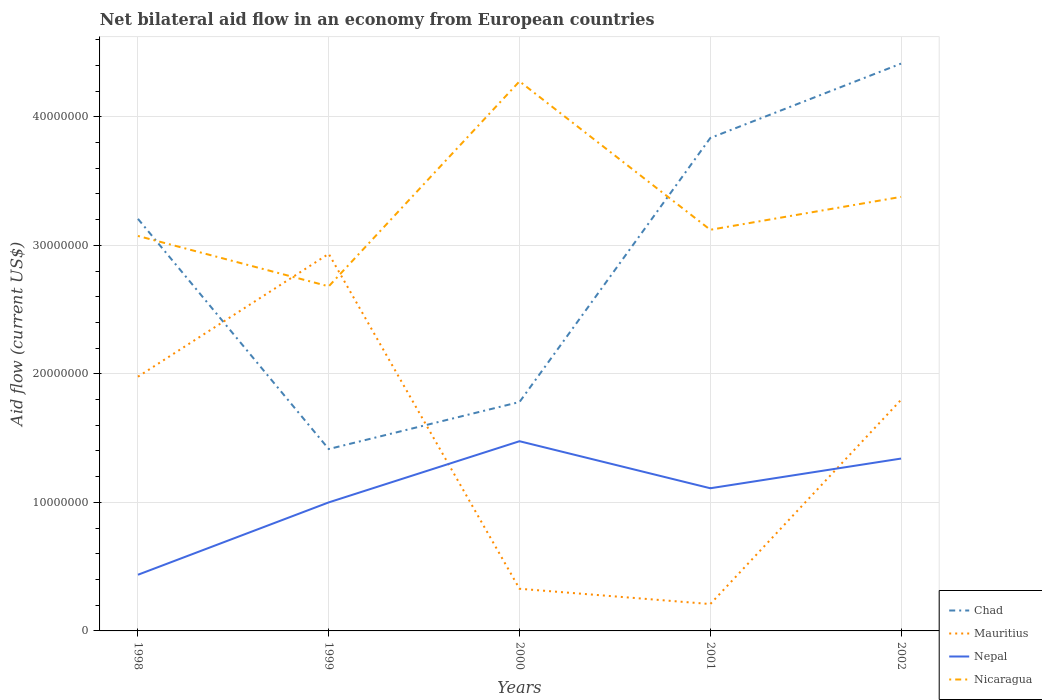How many different coloured lines are there?
Your answer should be very brief. 4. Is the number of lines equal to the number of legend labels?
Give a very brief answer. Yes. Across all years, what is the maximum net bilateral aid flow in Nepal?
Your answer should be very brief. 4.37e+06. What is the total net bilateral aid flow in Nicaragua in the graph?
Make the answer very short. 8.99e+06. What is the difference between the highest and the second highest net bilateral aid flow in Mauritius?
Your answer should be compact. 2.72e+07. Is the net bilateral aid flow in Mauritius strictly greater than the net bilateral aid flow in Nepal over the years?
Provide a short and direct response. No. How many lines are there?
Offer a terse response. 4. How many years are there in the graph?
Give a very brief answer. 5. What is the difference between two consecutive major ticks on the Y-axis?
Your answer should be compact. 1.00e+07. Are the values on the major ticks of Y-axis written in scientific E-notation?
Make the answer very short. No. How many legend labels are there?
Provide a succinct answer. 4. How are the legend labels stacked?
Offer a terse response. Vertical. What is the title of the graph?
Offer a terse response. Net bilateral aid flow in an economy from European countries. Does "Maldives" appear as one of the legend labels in the graph?
Your answer should be compact. No. What is the Aid flow (current US$) in Chad in 1998?
Keep it short and to the point. 3.21e+07. What is the Aid flow (current US$) in Mauritius in 1998?
Your answer should be very brief. 1.98e+07. What is the Aid flow (current US$) of Nepal in 1998?
Offer a very short reply. 4.37e+06. What is the Aid flow (current US$) of Nicaragua in 1998?
Offer a terse response. 3.07e+07. What is the Aid flow (current US$) in Chad in 1999?
Provide a short and direct response. 1.42e+07. What is the Aid flow (current US$) of Mauritius in 1999?
Provide a succinct answer. 2.93e+07. What is the Aid flow (current US$) in Nepal in 1999?
Give a very brief answer. 1.00e+07. What is the Aid flow (current US$) of Nicaragua in 1999?
Your answer should be very brief. 2.68e+07. What is the Aid flow (current US$) in Chad in 2000?
Ensure brevity in your answer.  1.78e+07. What is the Aid flow (current US$) in Mauritius in 2000?
Your answer should be compact. 3.28e+06. What is the Aid flow (current US$) of Nepal in 2000?
Your answer should be very brief. 1.48e+07. What is the Aid flow (current US$) of Nicaragua in 2000?
Your answer should be compact. 4.28e+07. What is the Aid flow (current US$) of Chad in 2001?
Offer a terse response. 3.84e+07. What is the Aid flow (current US$) of Mauritius in 2001?
Your response must be concise. 2.09e+06. What is the Aid flow (current US$) of Nepal in 2001?
Your answer should be very brief. 1.11e+07. What is the Aid flow (current US$) of Nicaragua in 2001?
Your answer should be compact. 3.12e+07. What is the Aid flow (current US$) in Chad in 2002?
Your response must be concise. 4.41e+07. What is the Aid flow (current US$) in Mauritius in 2002?
Give a very brief answer. 1.80e+07. What is the Aid flow (current US$) in Nepal in 2002?
Offer a very short reply. 1.34e+07. What is the Aid flow (current US$) in Nicaragua in 2002?
Your answer should be compact. 3.38e+07. Across all years, what is the maximum Aid flow (current US$) of Chad?
Provide a short and direct response. 4.41e+07. Across all years, what is the maximum Aid flow (current US$) of Mauritius?
Provide a succinct answer. 2.93e+07. Across all years, what is the maximum Aid flow (current US$) in Nepal?
Your answer should be compact. 1.48e+07. Across all years, what is the maximum Aid flow (current US$) of Nicaragua?
Ensure brevity in your answer.  4.28e+07. Across all years, what is the minimum Aid flow (current US$) of Chad?
Provide a succinct answer. 1.42e+07. Across all years, what is the minimum Aid flow (current US$) in Mauritius?
Provide a short and direct response. 2.09e+06. Across all years, what is the minimum Aid flow (current US$) of Nepal?
Make the answer very short. 4.37e+06. Across all years, what is the minimum Aid flow (current US$) in Nicaragua?
Ensure brevity in your answer.  2.68e+07. What is the total Aid flow (current US$) of Chad in the graph?
Your response must be concise. 1.47e+08. What is the total Aid flow (current US$) of Mauritius in the graph?
Offer a terse response. 7.25e+07. What is the total Aid flow (current US$) in Nepal in the graph?
Provide a succinct answer. 5.36e+07. What is the total Aid flow (current US$) in Nicaragua in the graph?
Make the answer very short. 1.65e+08. What is the difference between the Aid flow (current US$) of Chad in 1998 and that in 1999?
Keep it short and to the point. 1.79e+07. What is the difference between the Aid flow (current US$) of Mauritius in 1998 and that in 1999?
Give a very brief answer. -9.56e+06. What is the difference between the Aid flow (current US$) in Nepal in 1998 and that in 1999?
Provide a short and direct response. -5.63e+06. What is the difference between the Aid flow (current US$) in Nicaragua in 1998 and that in 1999?
Keep it short and to the point. 3.92e+06. What is the difference between the Aid flow (current US$) in Chad in 1998 and that in 2000?
Your response must be concise. 1.42e+07. What is the difference between the Aid flow (current US$) of Mauritius in 1998 and that in 2000?
Keep it short and to the point. 1.65e+07. What is the difference between the Aid flow (current US$) of Nepal in 1998 and that in 2000?
Your answer should be very brief. -1.04e+07. What is the difference between the Aid flow (current US$) of Nicaragua in 1998 and that in 2000?
Provide a short and direct response. -1.20e+07. What is the difference between the Aid flow (current US$) in Chad in 1998 and that in 2001?
Keep it short and to the point. -6.29e+06. What is the difference between the Aid flow (current US$) in Mauritius in 1998 and that in 2001?
Offer a very short reply. 1.77e+07. What is the difference between the Aid flow (current US$) in Nepal in 1998 and that in 2001?
Provide a succinct answer. -6.73e+06. What is the difference between the Aid flow (current US$) of Nicaragua in 1998 and that in 2001?
Offer a terse response. -4.80e+05. What is the difference between the Aid flow (current US$) in Chad in 1998 and that in 2002?
Provide a short and direct response. -1.21e+07. What is the difference between the Aid flow (current US$) in Mauritius in 1998 and that in 2002?
Your answer should be compact. 1.80e+06. What is the difference between the Aid flow (current US$) in Nepal in 1998 and that in 2002?
Offer a very short reply. -9.04e+06. What is the difference between the Aid flow (current US$) of Nicaragua in 1998 and that in 2002?
Offer a very short reply. -3.04e+06. What is the difference between the Aid flow (current US$) in Chad in 1999 and that in 2000?
Provide a succinct answer. -3.66e+06. What is the difference between the Aid flow (current US$) in Mauritius in 1999 and that in 2000?
Your answer should be compact. 2.61e+07. What is the difference between the Aid flow (current US$) in Nepal in 1999 and that in 2000?
Offer a terse response. -4.76e+06. What is the difference between the Aid flow (current US$) in Nicaragua in 1999 and that in 2000?
Your answer should be very brief. -1.60e+07. What is the difference between the Aid flow (current US$) of Chad in 1999 and that in 2001?
Your response must be concise. -2.42e+07. What is the difference between the Aid flow (current US$) of Mauritius in 1999 and that in 2001?
Your response must be concise. 2.72e+07. What is the difference between the Aid flow (current US$) of Nepal in 1999 and that in 2001?
Offer a very short reply. -1.10e+06. What is the difference between the Aid flow (current US$) of Nicaragua in 1999 and that in 2001?
Keep it short and to the point. -4.40e+06. What is the difference between the Aid flow (current US$) of Chad in 1999 and that in 2002?
Your answer should be compact. -3.00e+07. What is the difference between the Aid flow (current US$) of Mauritius in 1999 and that in 2002?
Your answer should be very brief. 1.14e+07. What is the difference between the Aid flow (current US$) in Nepal in 1999 and that in 2002?
Give a very brief answer. -3.41e+06. What is the difference between the Aid flow (current US$) in Nicaragua in 1999 and that in 2002?
Keep it short and to the point. -6.96e+06. What is the difference between the Aid flow (current US$) in Chad in 2000 and that in 2001?
Ensure brevity in your answer.  -2.05e+07. What is the difference between the Aid flow (current US$) of Mauritius in 2000 and that in 2001?
Keep it short and to the point. 1.19e+06. What is the difference between the Aid flow (current US$) of Nepal in 2000 and that in 2001?
Your response must be concise. 3.66e+06. What is the difference between the Aid flow (current US$) in Nicaragua in 2000 and that in 2001?
Make the answer very short. 1.16e+07. What is the difference between the Aid flow (current US$) in Chad in 2000 and that in 2002?
Your response must be concise. -2.63e+07. What is the difference between the Aid flow (current US$) of Mauritius in 2000 and that in 2002?
Your response must be concise. -1.47e+07. What is the difference between the Aid flow (current US$) of Nepal in 2000 and that in 2002?
Give a very brief answer. 1.35e+06. What is the difference between the Aid flow (current US$) in Nicaragua in 2000 and that in 2002?
Offer a very short reply. 8.99e+06. What is the difference between the Aid flow (current US$) in Chad in 2001 and that in 2002?
Your answer should be very brief. -5.79e+06. What is the difference between the Aid flow (current US$) of Mauritius in 2001 and that in 2002?
Your response must be concise. -1.59e+07. What is the difference between the Aid flow (current US$) of Nepal in 2001 and that in 2002?
Provide a succinct answer. -2.31e+06. What is the difference between the Aid flow (current US$) in Nicaragua in 2001 and that in 2002?
Make the answer very short. -2.56e+06. What is the difference between the Aid flow (current US$) in Chad in 1998 and the Aid flow (current US$) in Mauritius in 1999?
Offer a very short reply. 2.72e+06. What is the difference between the Aid flow (current US$) in Chad in 1998 and the Aid flow (current US$) in Nepal in 1999?
Provide a short and direct response. 2.21e+07. What is the difference between the Aid flow (current US$) in Chad in 1998 and the Aid flow (current US$) in Nicaragua in 1999?
Give a very brief answer. 5.25e+06. What is the difference between the Aid flow (current US$) in Mauritius in 1998 and the Aid flow (current US$) in Nepal in 1999?
Give a very brief answer. 9.78e+06. What is the difference between the Aid flow (current US$) in Mauritius in 1998 and the Aid flow (current US$) in Nicaragua in 1999?
Your answer should be compact. -7.03e+06. What is the difference between the Aid flow (current US$) in Nepal in 1998 and the Aid flow (current US$) in Nicaragua in 1999?
Keep it short and to the point. -2.24e+07. What is the difference between the Aid flow (current US$) of Chad in 1998 and the Aid flow (current US$) of Mauritius in 2000?
Your response must be concise. 2.88e+07. What is the difference between the Aid flow (current US$) in Chad in 1998 and the Aid flow (current US$) in Nepal in 2000?
Your response must be concise. 1.73e+07. What is the difference between the Aid flow (current US$) in Chad in 1998 and the Aid flow (current US$) in Nicaragua in 2000?
Your answer should be compact. -1.07e+07. What is the difference between the Aid flow (current US$) of Mauritius in 1998 and the Aid flow (current US$) of Nepal in 2000?
Your response must be concise. 5.02e+06. What is the difference between the Aid flow (current US$) in Mauritius in 1998 and the Aid flow (current US$) in Nicaragua in 2000?
Ensure brevity in your answer.  -2.30e+07. What is the difference between the Aid flow (current US$) of Nepal in 1998 and the Aid flow (current US$) of Nicaragua in 2000?
Keep it short and to the point. -3.84e+07. What is the difference between the Aid flow (current US$) in Chad in 1998 and the Aid flow (current US$) in Mauritius in 2001?
Offer a very short reply. 3.00e+07. What is the difference between the Aid flow (current US$) of Chad in 1998 and the Aid flow (current US$) of Nepal in 2001?
Your response must be concise. 2.10e+07. What is the difference between the Aid flow (current US$) of Chad in 1998 and the Aid flow (current US$) of Nicaragua in 2001?
Keep it short and to the point. 8.50e+05. What is the difference between the Aid flow (current US$) of Mauritius in 1998 and the Aid flow (current US$) of Nepal in 2001?
Ensure brevity in your answer.  8.68e+06. What is the difference between the Aid flow (current US$) in Mauritius in 1998 and the Aid flow (current US$) in Nicaragua in 2001?
Ensure brevity in your answer.  -1.14e+07. What is the difference between the Aid flow (current US$) of Nepal in 1998 and the Aid flow (current US$) of Nicaragua in 2001?
Provide a short and direct response. -2.68e+07. What is the difference between the Aid flow (current US$) of Chad in 1998 and the Aid flow (current US$) of Mauritius in 2002?
Offer a very short reply. 1.41e+07. What is the difference between the Aid flow (current US$) in Chad in 1998 and the Aid flow (current US$) in Nepal in 2002?
Provide a short and direct response. 1.86e+07. What is the difference between the Aid flow (current US$) of Chad in 1998 and the Aid flow (current US$) of Nicaragua in 2002?
Make the answer very short. -1.71e+06. What is the difference between the Aid flow (current US$) in Mauritius in 1998 and the Aid flow (current US$) in Nepal in 2002?
Make the answer very short. 6.37e+06. What is the difference between the Aid flow (current US$) of Mauritius in 1998 and the Aid flow (current US$) of Nicaragua in 2002?
Your answer should be very brief. -1.40e+07. What is the difference between the Aid flow (current US$) of Nepal in 1998 and the Aid flow (current US$) of Nicaragua in 2002?
Keep it short and to the point. -2.94e+07. What is the difference between the Aid flow (current US$) in Chad in 1999 and the Aid flow (current US$) in Mauritius in 2000?
Keep it short and to the point. 1.09e+07. What is the difference between the Aid flow (current US$) of Chad in 1999 and the Aid flow (current US$) of Nepal in 2000?
Give a very brief answer. -6.10e+05. What is the difference between the Aid flow (current US$) in Chad in 1999 and the Aid flow (current US$) in Nicaragua in 2000?
Provide a succinct answer. -2.86e+07. What is the difference between the Aid flow (current US$) of Mauritius in 1999 and the Aid flow (current US$) of Nepal in 2000?
Offer a terse response. 1.46e+07. What is the difference between the Aid flow (current US$) in Mauritius in 1999 and the Aid flow (current US$) in Nicaragua in 2000?
Provide a short and direct response. -1.34e+07. What is the difference between the Aid flow (current US$) in Nepal in 1999 and the Aid flow (current US$) in Nicaragua in 2000?
Your answer should be very brief. -3.28e+07. What is the difference between the Aid flow (current US$) in Chad in 1999 and the Aid flow (current US$) in Mauritius in 2001?
Your response must be concise. 1.21e+07. What is the difference between the Aid flow (current US$) of Chad in 1999 and the Aid flow (current US$) of Nepal in 2001?
Make the answer very short. 3.05e+06. What is the difference between the Aid flow (current US$) of Chad in 1999 and the Aid flow (current US$) of Nicaragua in 2001?
Your answer should be compact. -1.71e+07. What is the difference between the Aid flow (current US$) in Mauritius in 1999 and the Aid flow (current US$) in Nepal in 2001?
Provide a short and direct response. 1.82e+07. What is the difference between the Aid flow (current US$) of Mauritius in 1999 and the Aid flow (current US$) of Nicaragua in 2001?
Offer a very short reply. -1.87e+06. What is the difference between the Aid flow (current US$) in Nepal in 1999 and the Aid flow (current US$) in Nicaragua in 2001?
Your answer should be compact. -2.12e+07. What is the difference between the Aid flow (current US$) in Chad in 1999 and the Aid flow (current US$) in Mauritius in 2002?
Offer a very short reply. -3.83e+06. What is the difference between the Aid flow (current US$) of Chad in 1999 and the Aid flow (current US$) of Nepal in 2002?
Your answer should be compact. 7.40e+05. What is the difference between the Aid flow (current US$) in Chad in 1999 and the Aid flow (current US$) in Nicaragua in 2002?
Provide a succinct answer. -1.96e+07. What is the difference between the Aid flow (current US$) of Mauritius in 1999 and the Aid flow (current US$) of Nepal in 2002?
Keep it short and to the point. 1.59e+07. What is the difference between the Aid flow (current US$) in Mauritius in 1999 and the Aid flow (current US$) in Nicaragua in 2002?
Ensure brevity in your answer.  -4.43e+06. What is the difference between the Aid flow (current US$) of Nepal in 1999 and the Aid flow (current US$) of Nicaragua in 2002?
Keep it short and to the point. -2.38e+07. What is the difference between the Aid flow (current US$) of Chad in 2000 and the Aid flow (current US$) of Mauritius in 2001?
Your response must be concise. 1.57e+07. What is the difference between the Aid flow (current US$) of Chad in 2000 and the Aid flow (current US$) of Nepal in 2001?
Provide a short and direct response. 6.71e+06. What is the difference between the Aid flow (current US$) in Chad in 2000 and the Aid flow (current US$) in Nicaragua in 2001?
Provide a succinct answer. -1.34e+07. What is the difference between the Aid flow (current US$) in Mauritius in 2000 and the Aid flow (current US$) in Nepal in 2001?
Your answer should be very brief. -7.82e+06. What is the difference between the Aid flow (current US$) in Mauritius in 2000 and the Aid flow (current US$) in Nicaragua in 2001?
Your answer should be very brief. -2.79e+07. What is the difference between the Aid flow (current US$) in Nepal in 2000 and the Aid flow (current US$) in Nicaragua in 2001?
Your answer should be very brief. -1.64e+07. What is the difference between the Aid flow (current US$) of Chad in 2000 and the Aid flow (current US$) of Nepal in 2002?
Make the answer very short. 4.40e+06. What is the difference between the Aid flow (current US$) of Chad in 2000 and the Aid flow (current US$) of Nicaragua in 2002?
Offer a terse response. -1.60e+07. What is the difference between the Aid flow (current US$) of Mauritius in 2000 and the Aid flow (current US$) of Nepal in 2002?
Keep it short and to the point. -1.01e+07. What is the difference between the Aid flow (current US$) in Mauritius in 2000 and the Aid flow (current US$) in Nicaragua in 2002?
Your response must be concise. -3.05e+07. What is the difference between the Aid flow (current US$) in Nepal in 2000 and the Aid flow (current US$) in Nicaragua in 2002?
Offer a terse response. -1.90e+07. What is the difference between the Aid flow (current US$) of Chad in 2001 and the Aid flow (current US$) of Mauritius in 2002?
Your response must be concise. 2.04e+07. What is the difference between the Aid flow (current US$) of Chad in 2001 and the Aid flow (current US$) of Nepal in 2002?
Your response must be concise. 2.49e+07. What is the difference between the Aid flow (current US$) of Chad in 2001 and the Aid flow (current US$) of Nicaragua in 2002?
Offer a terse response. 4.58e+06. What is the difference between the Aid flow (current US$) in Mauritius in 2001 and the Aid flow (current US$) in Nepal in 2002?
Give a very brief answer. -1.13e+07. What is the difference between the Aid flow (current US$) in Mauritius in 2001 and the Aid flow (current US$) in Nicaragua in 2002?
Provide a short and direct response. -3.17e+07. What is the difference between the Aid flow (current US$) of Nepal in 2001 and the Aid flow (current US$) of Nicaragua in 2002?
Keep it short and to the point. -2.27e+07. What is the average Aid flow (current US$) of Chad per year?
Offer a terse response. 2.93e+07. What is the average Aid flow (current US$) of Mauritius per year?
Your answer should be very brief. 1.45e+07. What is the average Aid flow (current US$) of Nepal per year?
Offer a terse response. 1.07e+07. What is the average Aid flow (current US$) of Nicaragua per year?
Provide a succinct answer. 3.31e+07. In the year 1998, what is the difference between the Aid flow (current US$) of Chad and Aid flow (current US$) of Mauritius?
Ensure brevity in your answer.  1.23e+07. In the year 1998, what is the difference between the Aid flow (current US$) of Chad and Aid flow (current US$) of Nepal?
Offer a terse response. 2.77e+07. In the year 1998, what is the difference between the Aid flow (current US$) in Chad and Aid flow (current US$) in Nicaragua?
Give a very brief answer. 1.33e+06. In the year 1998, what is the difference between the Aid flow (current US$) in Mauritius and Aid flow (current US$) in Nepal?
Your answer should be compact. 1.54e+07. In the year 1998, what is the difference between the Aid flow (current US$) of Mauritius and Aid flow (current US$) of Nicaragua?
Offer a very short reply. -1.10e+07. In the year 1998, what is the difference between the Aid flow (current US$) of Nepal and Aid flow (current US$) of Nicaragua?
Offer a terse response. -2.64e+07. In the year 1999, what is the difference between the Aid flow (current US$) in Chad and Aid flow (current US$) in Mauritius?
Offer a terse response. -1.52e+07. In the year 1999, what is the difference between the Aid flow (current US$) in Chad and Aid flow (current US$) in Nepal?
Make the answer very short. 4.15e+06. In the year 1999, what is the difference between the Aid flow (current US$) of Chad and Aid flow (current US$) of Nicaragua?
Give a very brief answer. -1.27e+07. In the year 1999, what is the difference between the Aid flow (current US$) of Mauritius and Aid flow (current US$) of Nepal?
Make the answer very short. 1.93e+07. In the year 1999, what is the difference between the Aid flow (current US$) in Mauritius and Aid flow (current US$) in Nicaragua?
Offer a terse response. 2.53e+06. In the year 1999, what is the difference between the Aid flow (current US$) of Nepal and Aid flow (current US$) of Nicaragua?
Provide a succinct answer. -1.68e+07. In the year 2000, what is the difference between the Aid flow (current US$) of Chad and Aid flow (current US$) of Mauritius?
Your answer should be compact. 1.45e+07. In the year 2000, what is the difference between the Aid flow (current US$) of Chad and Aid flow (current US$) of Nepal?
Give a very brief answer. 3.05e+06. In the year 2000, what is the difference between the Aid flow (current US$) in Chad and Aid flow (current US$) in Nicaragua?
Give a very brief answer. -2.50e+07. In the year 2000, what is the difference between the Aid flow (current US$) in Mauritius and Aid flow (current US$) in Nepal?
Your answer should be very brief. -1.15e+07. In the year 2000, what is the difference between the Aid flow (current US$) of Mauritius and Aid flow (current US$) of Nicaragua?
Give a very brief answer. -3.95e+07. In the year 2000, what is the difference between the Aid flow (current US$) of Nepal and Aid flow (current US$) of Nicaragua?
Keep it short and to the point. -2.80e+07. In the year 2001, what is the difference between the Aid flow (current US$) of Chad and Aid flow (current US$) of Mauritius?
Your answer should be very brief. 3.63e+07. In the year 2001, what is the difference between the Aid flow (current US$) in Chad and Aid flow (current US$) in Nepal?
Provide a short and direct response. 2.72e+07. In the year 2001, what is the difference between the Aid flow (current US$) in Chad and Aid flow (current US$) in Nicaragua?
Provide a short and direct response. 7.14e+06. In the year 2001, what is the difference between the Aid flow (current US$) of Mauritius and Aid flow (current US$) of Nepal?
Offer a very short reply. -9.01e+06. In the year 2001, what is the difference between the Aid flow (current US$) of Mauritius and Aid flow (current US$) of Nicaragua?
Provide a succinct answer. -2.91e+07. In the year 2001, what is the difference between the Aid flow (current US$) in Nepal and Aid flow (current US$) in Nicaragua?
Your answer should be very brief. -2.01e+07. In the year 2002, what is the difference between the Aid flow (current US$) of Chad and Aid flow (current US$) of Mauritius?
Keep it short and to the point. 2.62e+07. In the year 2002, what is the difference between the Aid flow (current US$) of Chad and Aid flow (current US$) of Nepal?
Your response must be concise. 3.07e+07. In the year 2002, what is the difference between the Aid flow (current US$) in Chad and Aid flow (current US$) in Nicaragua?
Ensure brevity in your answer.  1.04e+07. In the year 2002, what is the difference between the Aid flow (current US$) in Mauritius and Aid flow (current US$) in Nepal?
Offer a very short reply. 4.57e+06. In the year 2002, what is the difference between the Aid flow (current US$) of Mauritius and Aid flow (current US$) of Nicaragua?
Provide a short and direct response. -1.58e+07. In the year 2002, what is the difference between the Aid flow (current US$) of Nepal and Aid flow (current US$) of Nicaragua?
Make the answer very short. -2.04e+07. What is the ratio of the Aid flow (current US$) of Chad in 1998 to that in 1999?
Your answer should be very brief. 2.27. What is the ratio of the Aid flow (current US$) in Mauritius in 1998 to that in 1999?
Your answer should be compact. 0.67. What is the ratio of the Aid flow (current US$) in Nepal in 1998 to that in 1999?
Offer a very short reply. 0.44. What is the ratio of the Aid flow (current US$) in Nicaragua in 1998 to that in 1999?
Your answer should be very brief. 1.15. What is the ratio of the Aid flow (current US$) of Chad in 1998 to that in 2000?
Provide a succinct answer. 1.8. What is the ratio of the Aid flow (current US$) of Mauritius in 1998 to that in 2000?
Provide a succinct answer. 6.03. What is the ratio of the Aid flow (current US$) of Nepal in 1998 to that in 2000?
Provide a short and direct response. 0.3. What is the ratio of the Aid flow (current US$) of Nicaragua in 1998 to that in 2000?
Your answer should be compact. 0.72. What is the ratio of the Aid flow (current US$) in Chad in 1998 to that in 2001?
Offer a very short reply. 0.84. What is the ratio of the Aid flow (current US$) of Mauritius in 1998 to that in 2001?
Your answer should be compact. 9.46. What is the ratio of the Aid flow (current US$) of Nepal in 1998 to that in 2001?
Your answer should be compact. 0.39. What is the ratio of the Aid flow (current US$) in Nicaragua in 1998 to that in 2001?
Provide a short and direct response. 0.98. What is the ratio of the Aid flow (current US$) of Chad in 1998 to that in 2002?
Your answer should be compact. 0.73. What is the ratio of the Aid flow (current US$) of Mauritius in 1998 to that in 2002?
Provide a succinct answer. 1.1. What is the ratio of the Aid flow (current US$) of Nepal in 1998 to that in 2002?
Make the answer very short. 0.33. What is the ratio of the Aid flow (current US$) of Nicaragua in 1998 to that in 2002?
Your response must be concise. 0.91. What is the ratio of the Aid flow (current US$) of Chad in 1999 to that in 2000?
Provide a short and direct response. 0.79. What is the ratio of the Aid flow (current US$) of Mauritius in 1999 to that in 2000?
Offer a terse response. 8.95. What is the ratio of the Aid flow (current US$) in Nepal in 1999 to that in 2000?
Provide a short and direct response. 0.68. What is the ratio of the Aid flow (current US$) of Nicaragua in 1999 to that in 2000?
Provide a short and direct response. 0.63. What is the ratio of the Aid flow (current US$) in Chad in 1999 to that in 2001?
Your response must be concise. 0.37. What is the ratio of the Aid flow (current US$) of Mauritius in 1999 to that in 2001?
Provide a short and direct response. 14.04. What is the ratio of the Aid flow (current US$) in Nepal in 1999 to that in 2001?
Make the answer very short. 0.9. What is the ratio of the Aid flow (current US$) of Nicaragua in 1999 to that in 2001?
Ensure brevity in your answer.  0.86. What is the ratio of the Aid flow (current US$) of Chad in 1999 to that in 2002?
Offer a terse response. 0.32. What is the ratio of the Aid flow (current US$) in Mauritius in 1999 to that in 2002?
Make the answer very short. 1.63. What is the ratio of the Aid flow (current US$) in Nepal in 1999 to that in 2002?
Your answer should be compact. 0.75. What is the ratio of the Aid flow (current US$) in Nicaragua in 1999 to that in 2002?
Your response must be concise. 0.79. What is the ratio of the Aid flow (current US$) in Chad in 2000 to that in 2001?
Provide a short and direct response. 0.46. What is the ratio of the Aid flow (current US$) in Mauritius in 2000 to that in 2001?
Your answer should be very brief. 1.57. What is the ratio of the Aid flow (current US$) in Nepal in 2000 to that in 2001?
Make the answer very short. 1.33. What is the ratio of the Aid flow (current US$) in Nicaragua in 2000 to that in 2001?
Offer a very short reply. 1.37. What is the ratio of the Aid flow (current US$) of Chad in 2000 to that in 2002?
Make the answer very short. 0.4. What is the ratio of the Aid flow (current US$) of Mauritius in 2000 to that in 2002?
Give a very brief answer. 0.18. What is the ratio of the Aid flow (current US$) of Nepal in 2000 to that in 2002?
Provide a succinct answer. 1.1. What is the ratio of the Aid flow (current US$) in Nicaragua in 2000 to that in 2002?
Your response must be concise. 1.27. What is the ratio of the Aid flow (current US$) in Chad in 2001 to that in 2002?
Your answer should be very brief. 0.87. What is the ratio of the Aid flow (current US$) in Mauritius in 2001 to that in 2002?
Make the answer very short. 0.12. What is the ratio of the Aid flow (current US$) in Nepal in 2001 to that in 2002?
Keep it short and to the point. 0.83. What is the ratio of the Aid flow (current US$) in Nicaragua in 2001 to that in 2002?
Ensure brevity in your answer.  0.92. What is the difference between the highest and the second highest Aid flow (current US$) of Chad?
Provide a short and direct response. 5.79e+06. What is the difference between the highest and the second highest Aid flow (current US$) of Mauritius?
Provide a short and direct response. 9.56e+06. What is the difference between the highest and the second highest Aid flow (current US$) in Nepal?
Offer a terse response. 1.35e+06. What is the difference between the highest and the second highest Aid flow (current US$) of Nicaragua?
Your answer should be compact. 8.99e+06. What is the difference between the highest and the lowest Aid flow (current US$) in Chad?
Provide a succinct answer. 3.00e+07. What is the difference between the highest and the lowest Aid flow (current US$) in Mauritius?
Offer a very short reply. 2.72e+07. What is the difference between the highest and the lowest Aid flow (current US$) in Nepal?
Ensure brevity in your answer.  1.04e+07. What is the difference between the highest and the lowest Aid flow (current US$) of Nicaragua?
Your answer should be compact. 1.60e+07. 